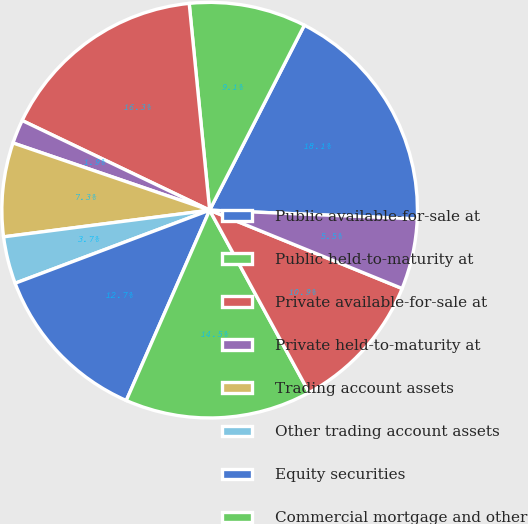Convert chart. <chart><loc_0><loc_0><loc_500><loc_500><pie_chart><fcel>Public available-for-sale at<fcel>Public held-to-maturity at<fcel>Private available-for-sale at<fcel>Private held-to-maturity at<fcel>Trading account assets<fcel>Other trading account assets<fcel>Equity securities<fcel>Commercial mortgage and other<fcel>Policy loans at outstanding<fcel>Other long-term investments(1)<nl><fcel>18.14%<fcel>9.1%<fcel>16.33%<fcel>1.86%<fcel>7.29%<fcel>3.67%<fcel>12.71%<fcel>14.52%<fcel>10.9%<fcel>5.48%<nl></chart> 